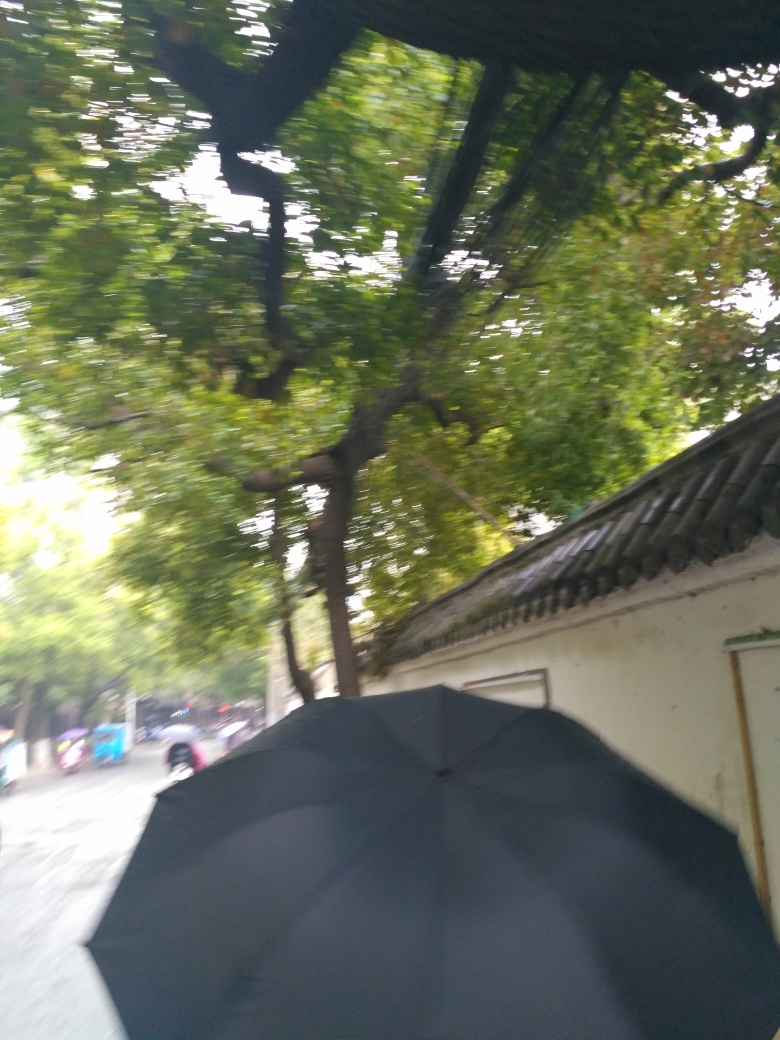What weather conditions are present in this image? The presence of an umbrella suggests it may be raining, and the overall grey tones of the image support the idea of overcast or rainy weather conditions. 